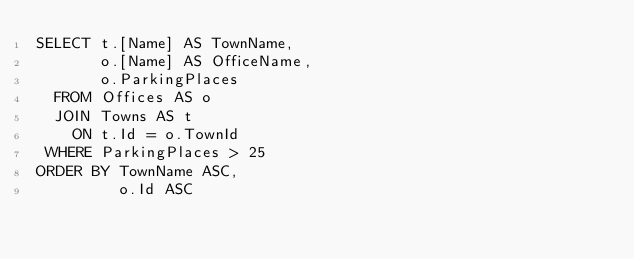Convert code to text. <code><loc_0><loc_0><loc_500><loc_500><_SQL_>SELECT t.[Name] AS TownName,
       o.[Name] AS OfficeName,
       o.ParkingPlaces
  FROM Offices AS o
  JOIN Towns AS t
    ON t.Id = o.TownId
 WHERE ParkingPlaces > 25
ORDER BY TownName ASC,
         o.Id ASC</code> 